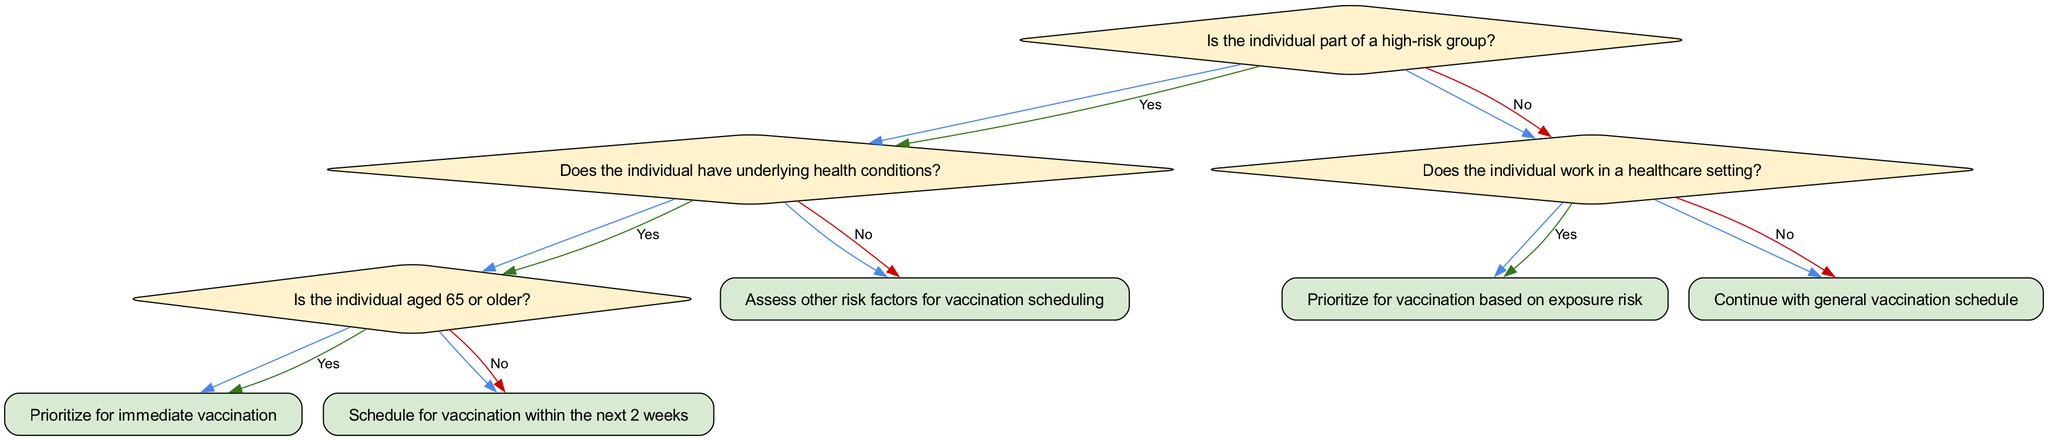What is the first question in the decision tree? The first question asked at the root of the decision tree is whether the individual is part of a high-risk group.
Answer: Is the individual part of a high-risk group? What action is taken if the individual has underlying health conditions and is aged 65 or older? If the individual has underlying health conditions and is 65 years or older, the action specified is to prioritize them for immediate vaccination.
Answer: Prioritize for immediate vaccination How many total questions are in the decision tree? The decision tree contains a total of 4 questions, as indicated by the different nodes that pose decisions about the individual’s health risks and status.
Answer: 4 What happens if the individual is not part of a high-risk group? If the individual is not part of a high-risk group, the next question is about their occupation, specifically whether they work in a healthcare setting.
Answer: Does the individual work in a healthcare setting? What action is recommended if the individual works in a healthcare setting? If the individual works in a healthcare setting, the action is to prioritize them for vaccination based on exposure risk.
Answer: Prioritize for vaccination based on exposure risk What is the action for individuals not belonging to a high-risk group and not working in healthcare? If the individual does not belong to a high-risk group and does not work in healthcare, the action is to continue with the general vaccination schedule.
Answer: Continue with general vaccination schedule What is the relationship between having underlying health conditions and the subsequent actions? If an individual is determined to have underlying health conditions, it leads to a further decision about their age, which determines whether they get vaccinated immediately or within two weeks.
Answer: Age determines vaccination timing What does the response lead to if the answer to the question about underlying conditions is 'No'? If the answer to the question about underlying health conditions is 'No', the action taken is to assess other risk factors for vaccination scheduling.
Answer: Assess other risk factors for vaccination scheduling 